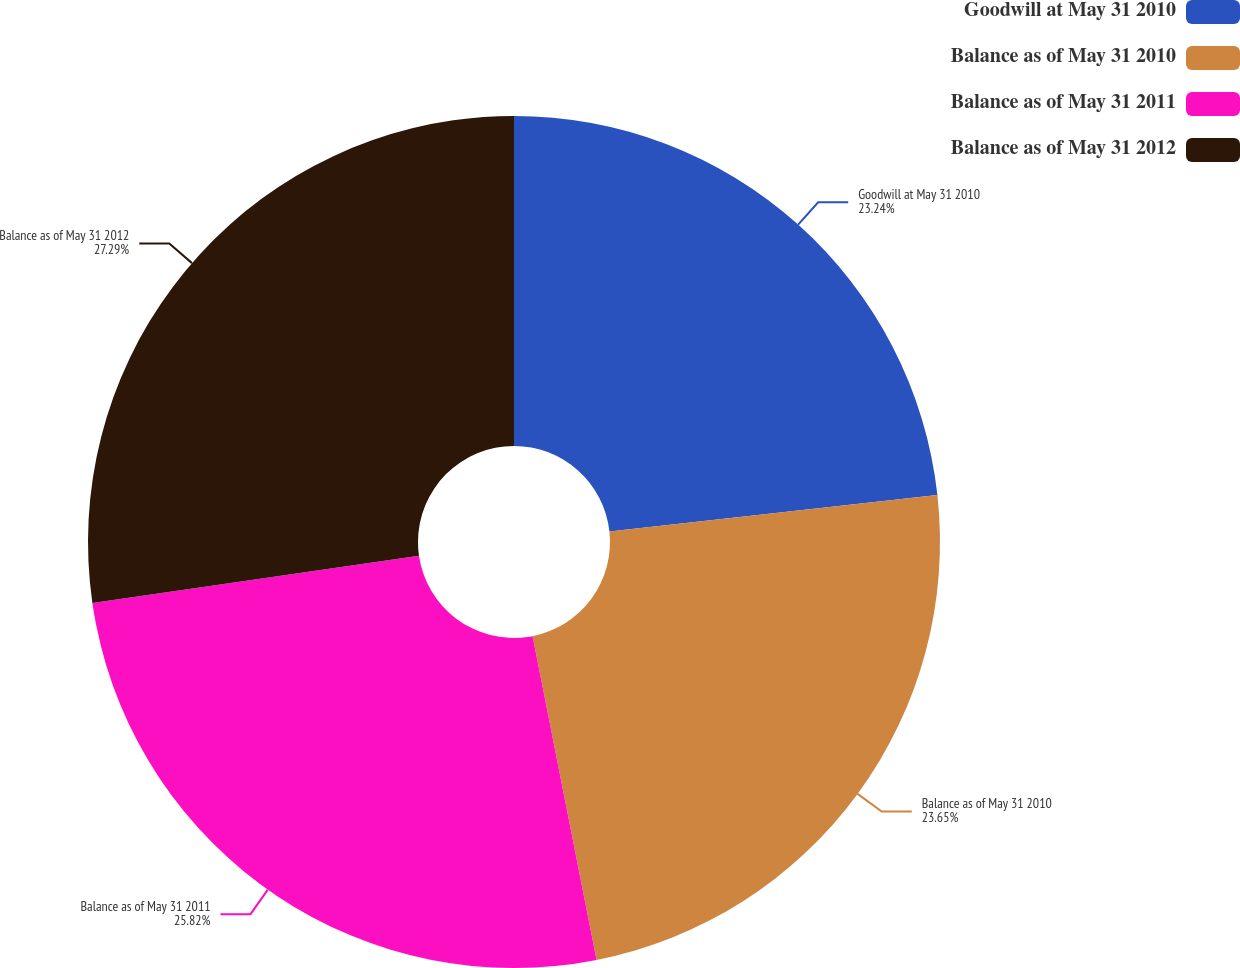Convert chart to OTSL. <chart><loc_0><loc_0><loc_500><loc_500><pie_chart><fcel>Goodwill at May 31 2010<fcel>Balance as of May 31 2010<fcel>Balance as of May 31 2011<fcel>Balance as of May 31 2012<nl><fcel>23.24%<fcel>23.65%<fcel>25.82%<fcel>27.28%<nl></chart> 